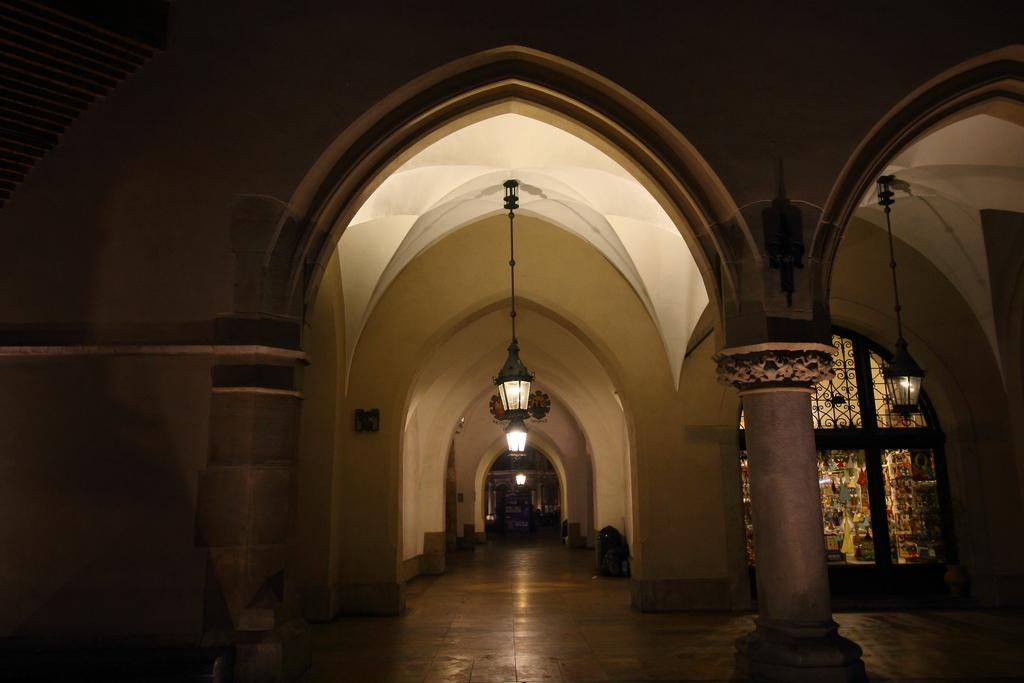Where was the image taken? The image was taken inside a building. What can be seen in the background of the image? There is an arch-like structure in the background. What is hanging from the roof in the image? Lights are hanged from the roof. What type of paint is used on the canvas in the image? There is no canvas or paint present in the image. How many people are participating in the feast in the image? There is no feast or people present in the image. 